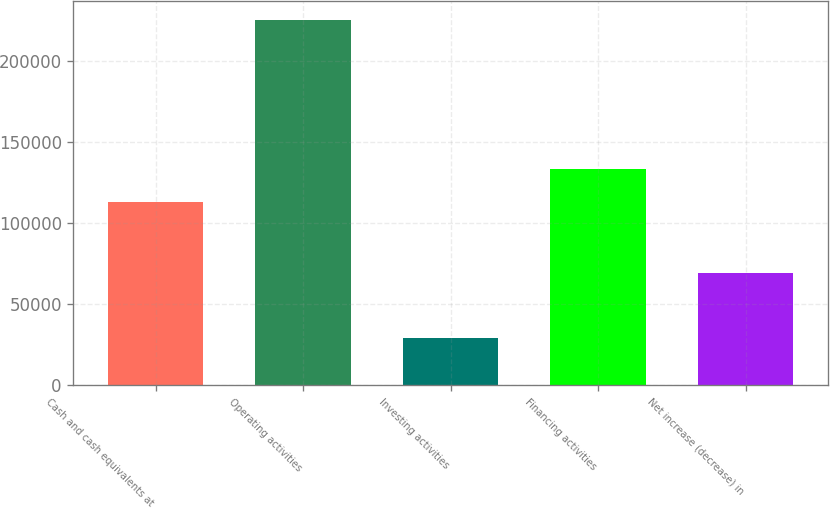<chart> <loc_0><loc_0><loc_500><loc_500><bar_chart><fcel>Cash and cash equivalents at<fcel>Operating activities<fcel>Investing activities<fcel>Financing activities<fcel>Net increase (decrease) in<nl><fcel>113159<fcel>225639<fcel>28873<fcel>133186<fcel>69255.6<nl></chart> 